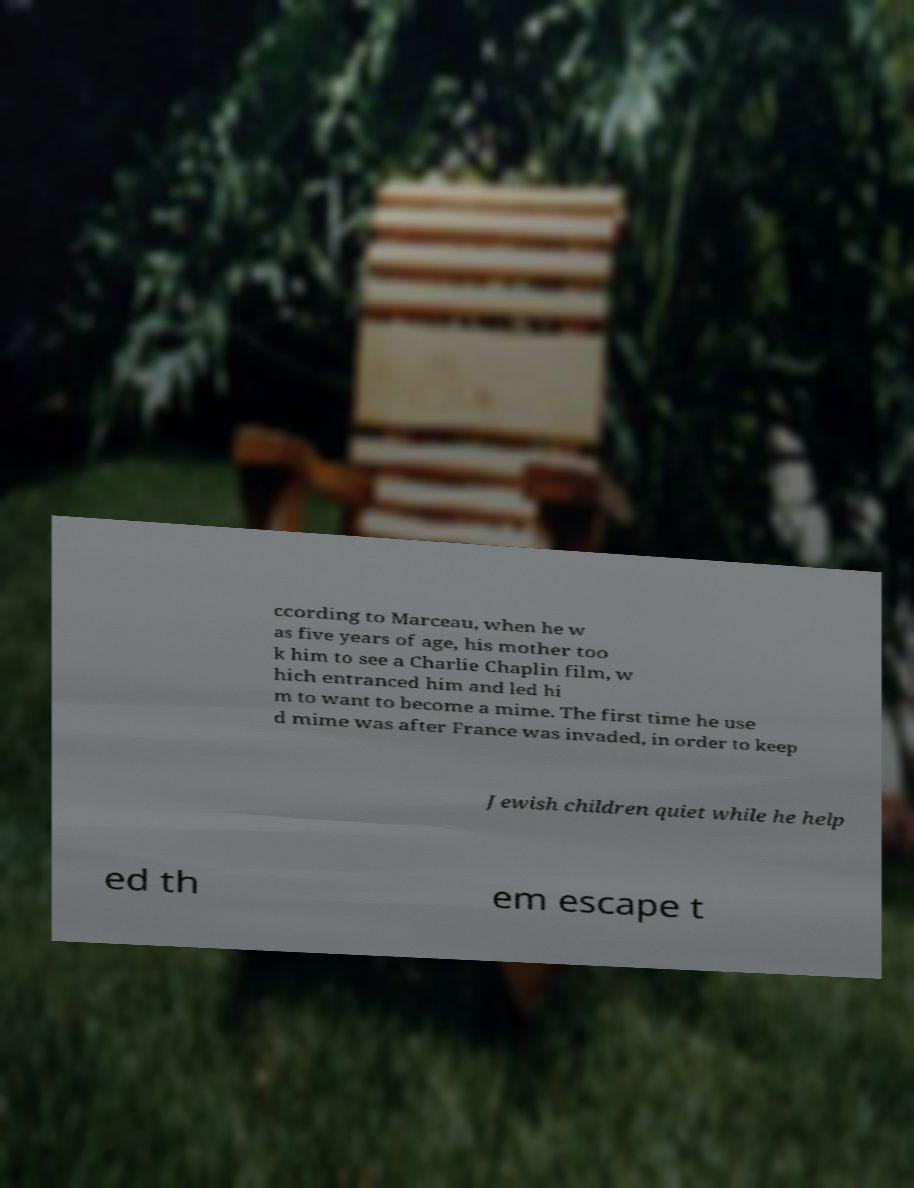Can you accurately transcribe the text from the provided image for me? ccording to Marceau, when he w as five years of age, his mother too k him to see a Charlie Chaplin film, w hich entranced him and led hi m to want to become a mime. The first time he use d mime was after France was invaded, in order to keep Jewish children quiet while he help ed th em escape t 